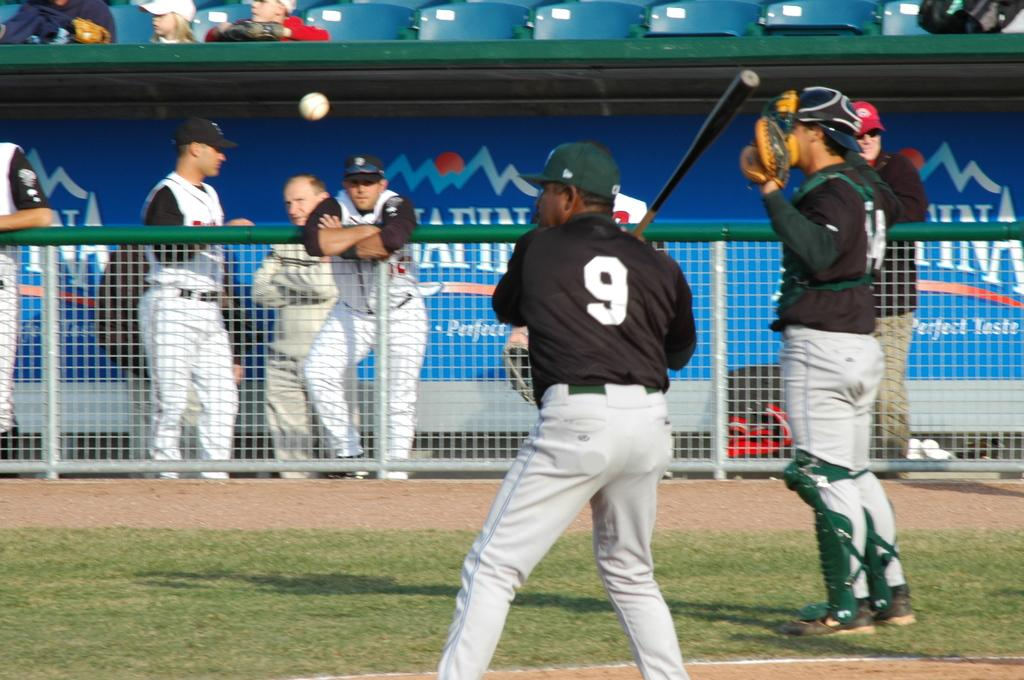<image>
Describe the image concisely. Number 9 is about to hit the baseball. 